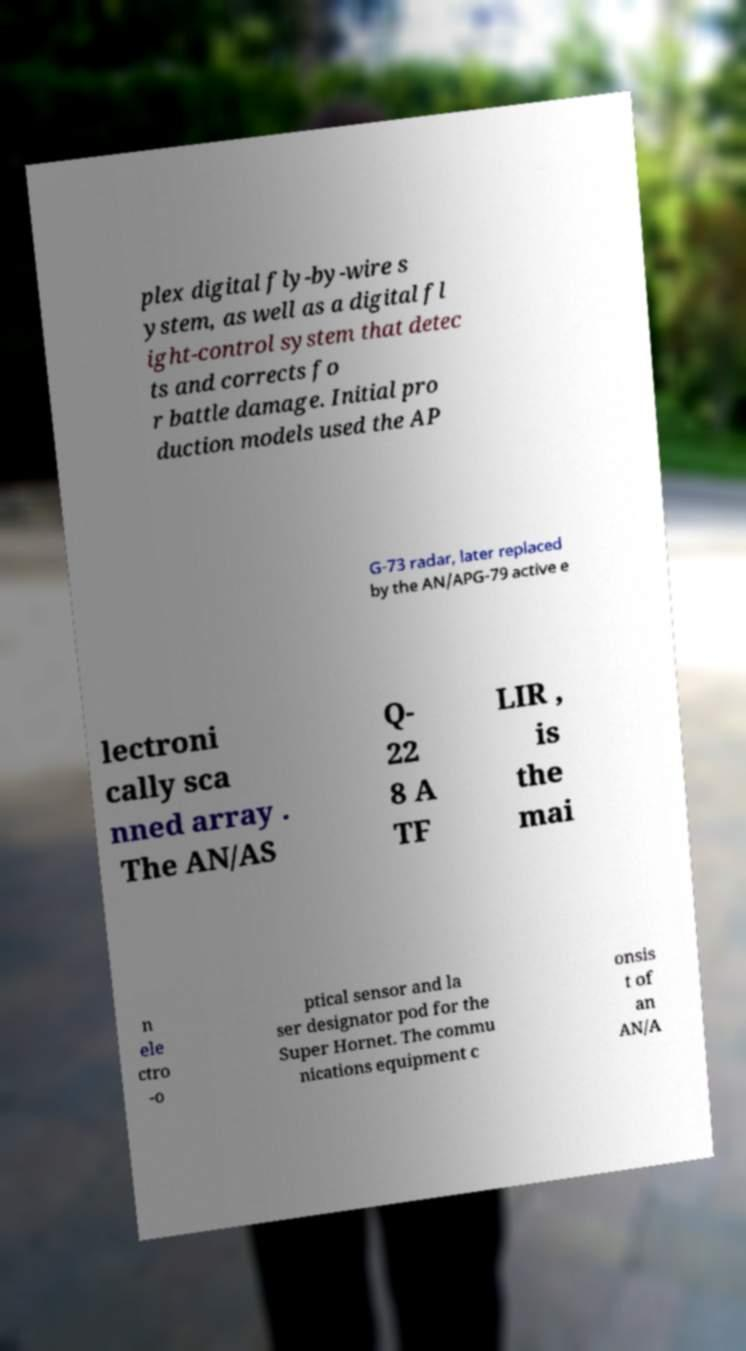There's text embedded in this image that I need extracted. Can you transcribe it verbatim? plex digital fly-by-wire s ystem, as well as a digital fl ight-control system that detec ts and corrects fo r battle damage. Initial pro duction models used the AP G-73 radar, later replaced by the AN/APG-79 active e lectroni cally sca nned array . The AN/AS Q- 22 8 A TF LIR , is the mai n ele ctro -o ptical sensor and la ser designator pod for the Super Hornet. The commu nications equipment c onsis t of an AN/A 